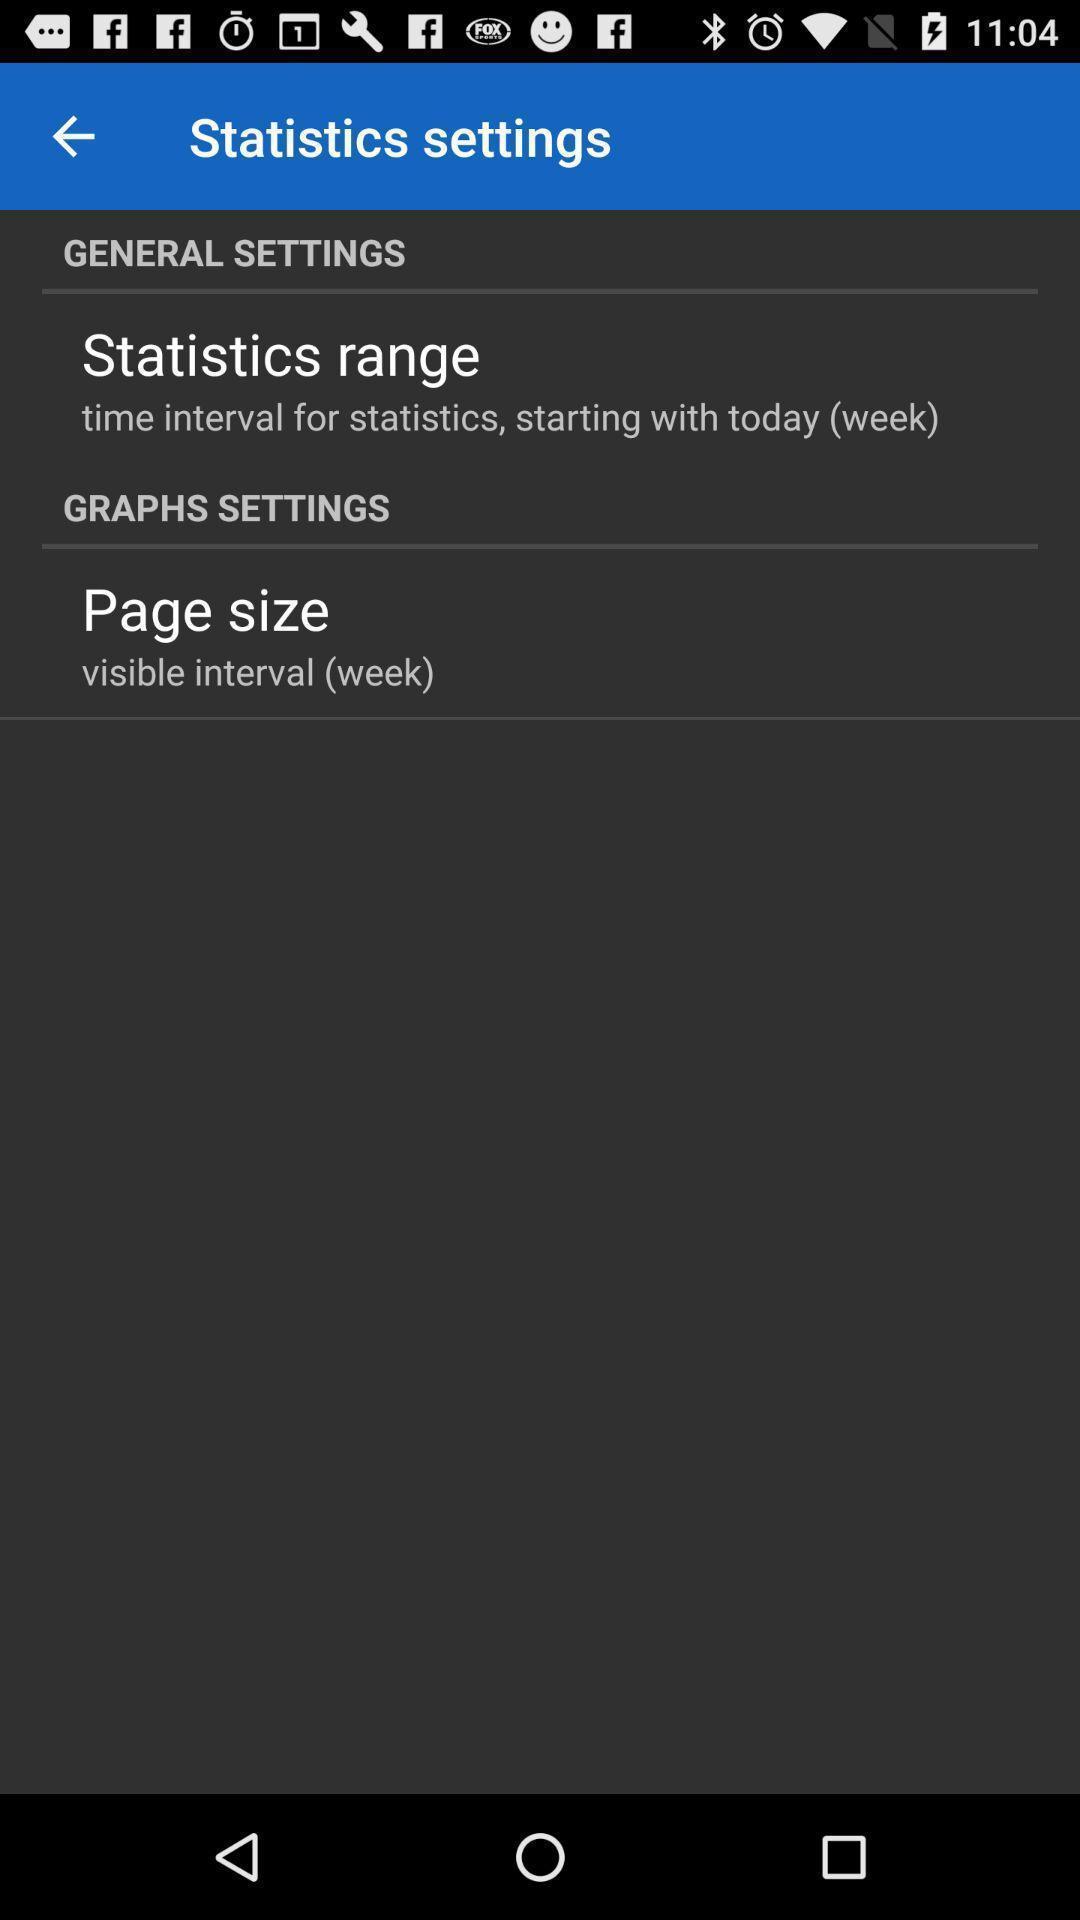Explain what's happening in this screen capture. Statistics settings of a baby care app are displaying. 